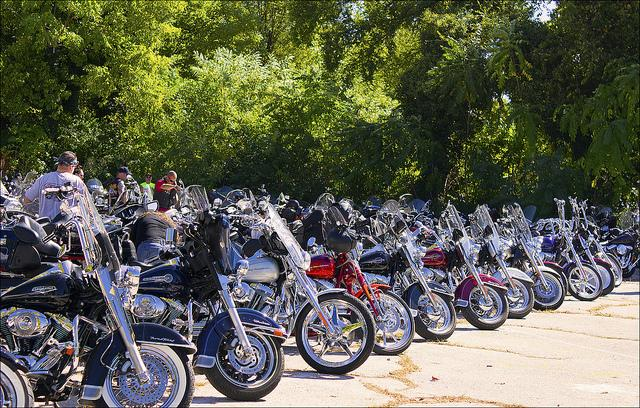Which direction are all the front wheels facing? right 